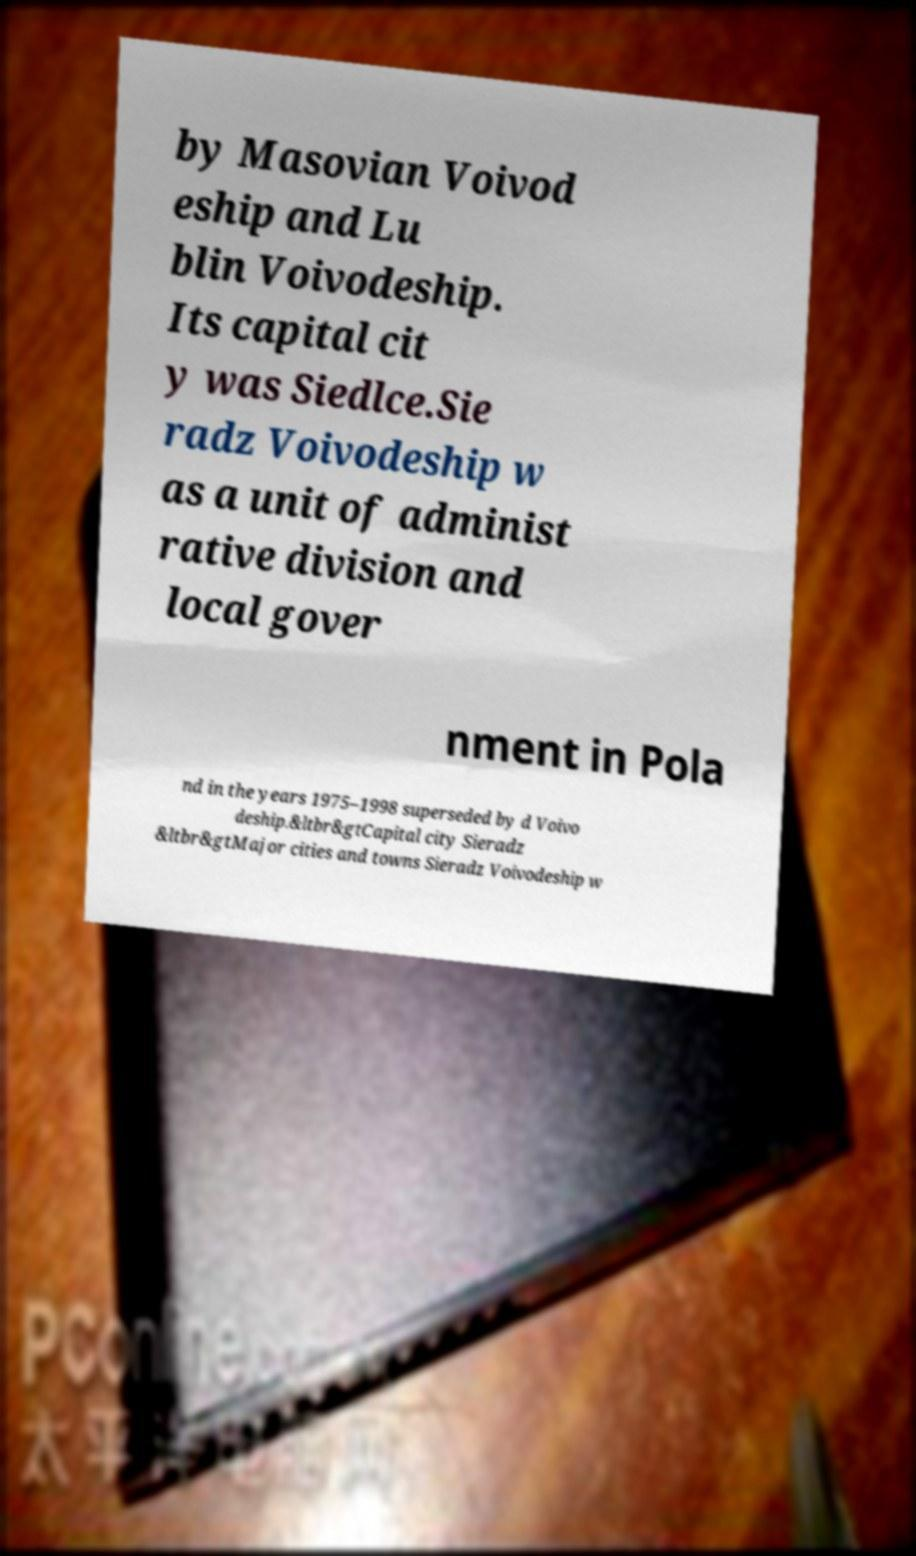I need the written content from this picture converted into text. Can you do that? by Masovian Voivod eship and Lu blin Voivodeship. Its capital cit y was Siedlce.Sie radz Voivodeship w as a unit of administ rative division and local gover nment in Pola nd in the years 1975–1998 superseded by d Voivo deship.&ltbr&gtCapital city Sieradz &ltbr&gtMajor cities and towns Sieradz Voivodeship w 